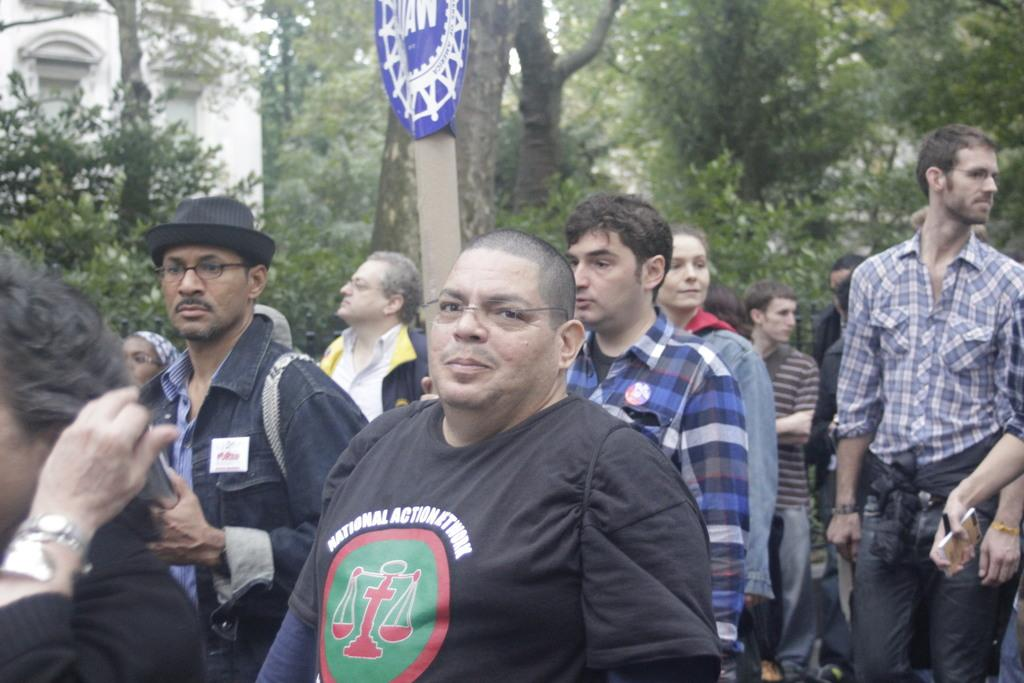<image>
Create a compact narrative representing the image presented. A man wearing a National Action Network T-Shirt gathers with others at a rally. 